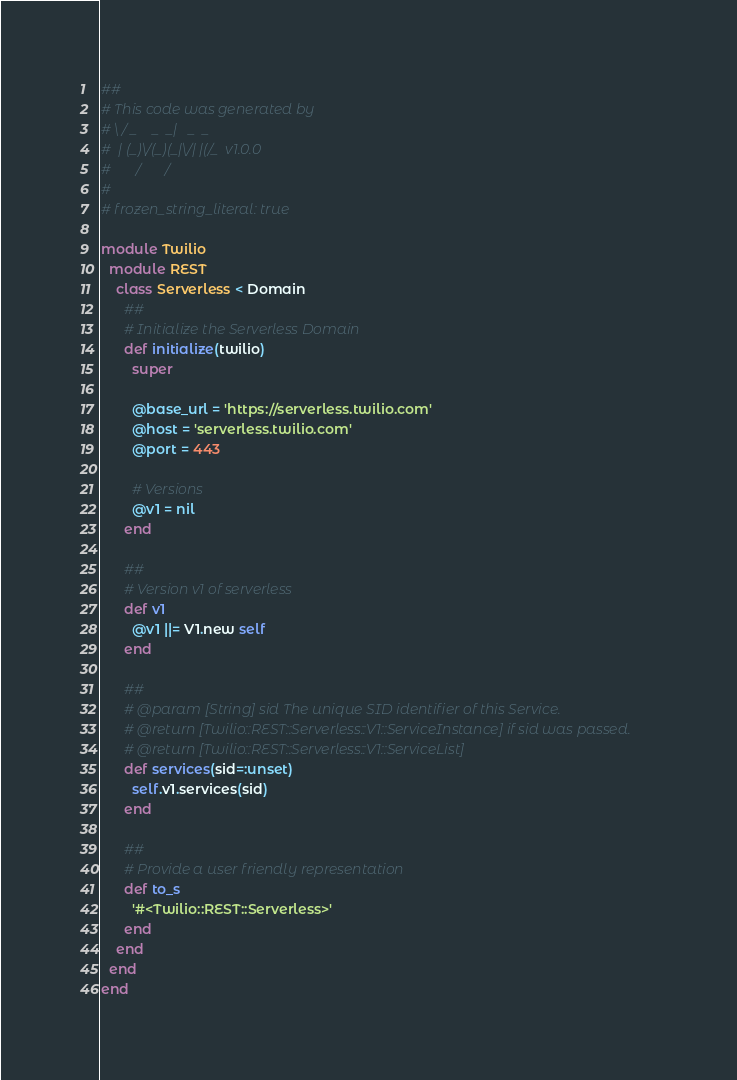<code> <loc_0><loc_0><loc_500><loc_500><_Ruby_>##
# This code was generated by
# \ / _    _  _|   _  _
#  | (_)\/(_)(_|\/| |(/_  v1.0.0
#       /       /
#
# frozen_string_literal: true

module Twilio
  module REST
    class Serverless < Domain
      ##
      # Initialize the Serverless Domain
      def initialize(twilio)
        super

        @base_url = 'https://serverless.twilio.com'
        @host = 'serverless.twilio.com'
        @port = 443

        # Versions
        @v1 = nil
      end

      ##
      # Version v1 of serverless
      def v1
        @v1 ||= V1.new self
      end

      ##
      # @param [String] sid The unique SID identifier of this Service.
      # @return [Twilio::REST::Serverless::V1::ServiceInstance] if sid was passed.
      # @return [Twilio::REST::Serverless::V1::ServiceList]
      def services(sid=:unset)
        self.v1.services(sid)
      end

      ##
      # Provide a user friendly representation
      def to_s
        '#<Twilio::REST::Serverless>'
      end
    end
  end
end</code> 